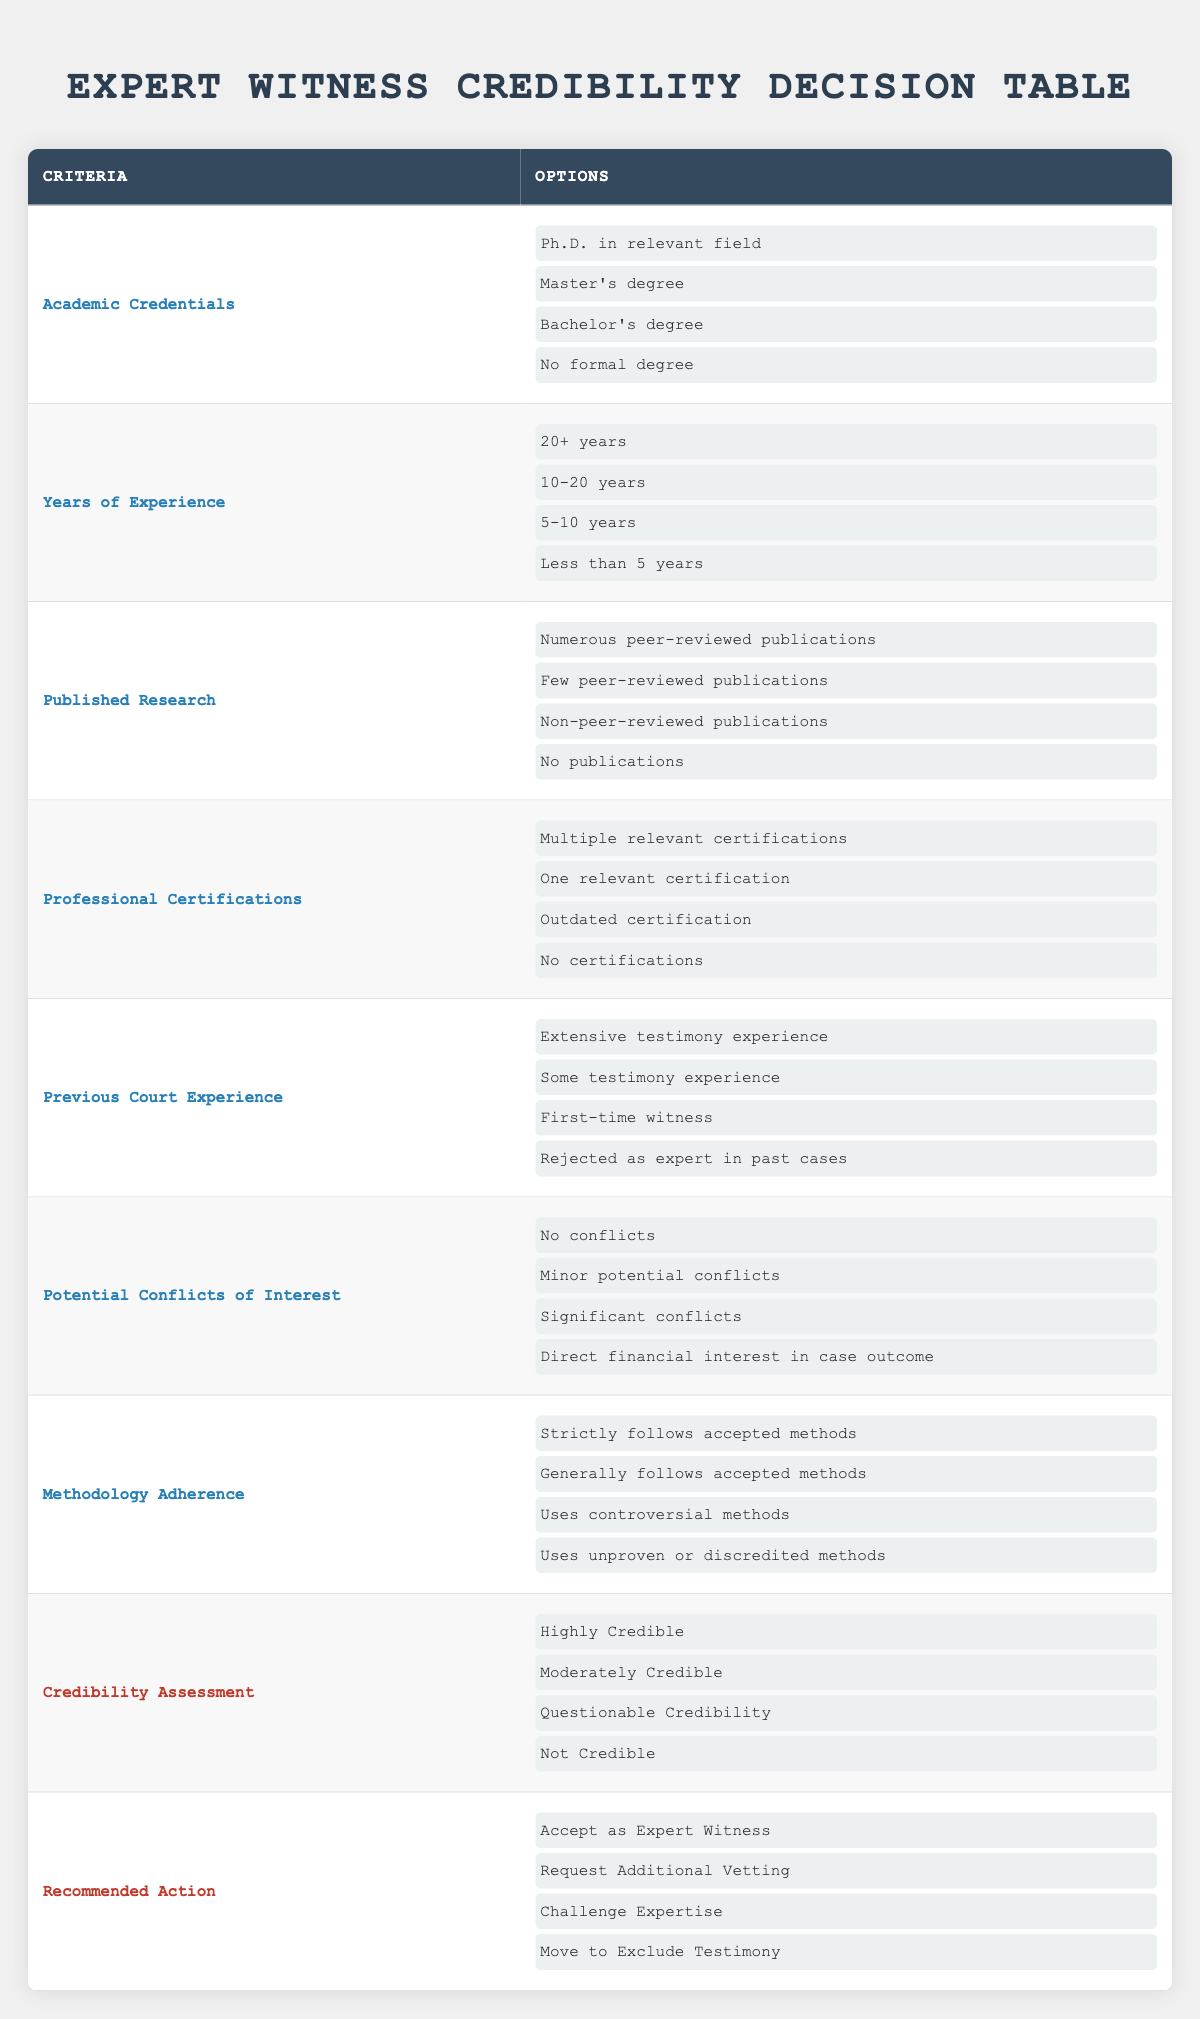What is the highest academic credential listed? The table lists four options under "Academic Credentials": Ph.D. in relevant field, Master's degree, Bachelor's degree, and No formal degree. The highest among these is the Ph.D. in relevant field.
Answer: Ph.D. in relevant field How many years of experience are categorized as '20+ years'? The table specifies four experience categories, one of which is '20+ years'. The options listed include 20+ years, 10-20 years, 5-10 years, and less than 5 years. There is only one entry for '20+ years'.
Answer: 1 Is having a ‘Direct financial interest in case outcome’ considered a significant conflict of interest? Yes, 'Direct financial interest in case outcome' is mentioned as one of the options under "Potential Conflicts of Interest," which also includes 'No conflicts' and 'Significant conflicts.' Therefore, it is categorized as such.
Answer: Yes What is the lowest credibility assessment listed? The "Credibility Assessment" options are Highly Credible, Moderately Credible, Questionable Credibility, and Not Credible. The lowest is Not Credible.
Answer: Not Credible If an expert has a Master’s degree, no certifications, and less than 5 years of experience, what would you likely assess their credibility as? First, we check their academic credential (Master's degree), which is moderate. Their experience (less than 5 years) would typically lower credibility. Without certifications, the overall picture points to 'Questionable Credibility' rather than 'Highly Credible'.
Answer: Questionable Credibility What are the two potential recommended actions for an expert with 'Some testimony experience' and 'One relevant certification'? From the table, 'Some testimony experience' indicates moderate familiarity with the court setting. Having 'One relevant certification' is a positive but limited sign of expertise. Thus, the recommended actions could likely be either 'Accept as Expert Witness' or 'Request Additional Vetting.' Both actions reflect the need for scrutiny.
Answer: Accept as Expert Witness or Request Additional Vetting What potential conflicts of interest would most disqualify a witness's credibility? The list under "Potential Conflicts of Interest" includes 'No conflicts,' 'Minor potential conflicts,' 'Significant conflicts,' and 'Direct financial interest in case outcome.' The option 'Direct financial interest in case outcome' would most severely disqualify a witness's credibility.
Answer: Direct financial interest in case outcome If an expert uses unproven or discredited methods, how would they likely be assessed? The table lists 'Uses unproven or discredited methods' under "Methodology Adherence," typically indicating poor practice. Therefore, a witness employing such methods would likely be assessed as having 'Not Credible' standing. This would affect their credibility assessment severely.
Answer: Not Credible What options fall under 'Published Research' that might impact credibility? The "Published Research" section lists 'Numerous peer-reviewed publications,' 'Few peer-reviewed publications,' 'Non-peer-reviewed publications,' and 'No publications.' The presence of peer-reviewed publications indicates greater credibility, while a lack thereof diminishes it.
Answer: Numerous peer-reviewed publications; Few peer-reviewed publications; Non-peer-reviewed publications; No publications 